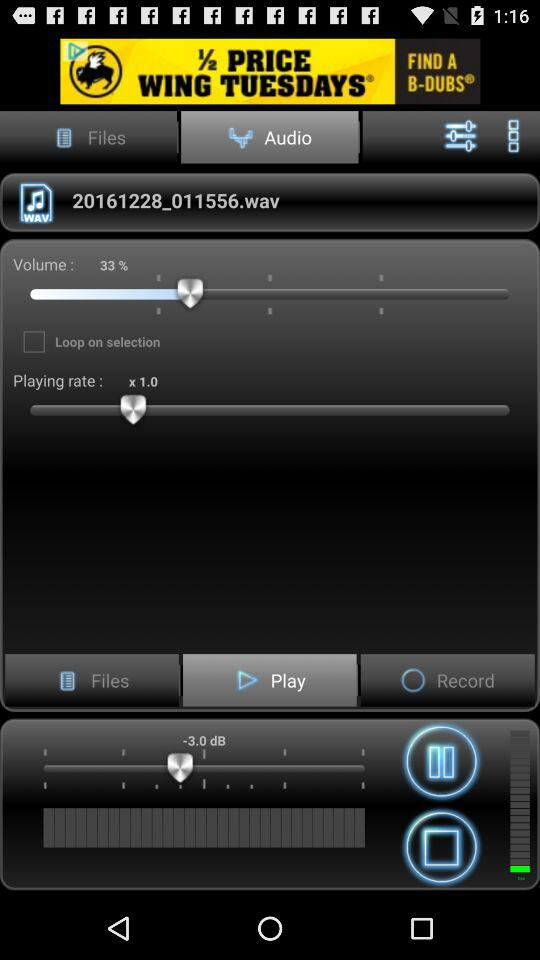What's the playing rate? The playing rate is 1. 